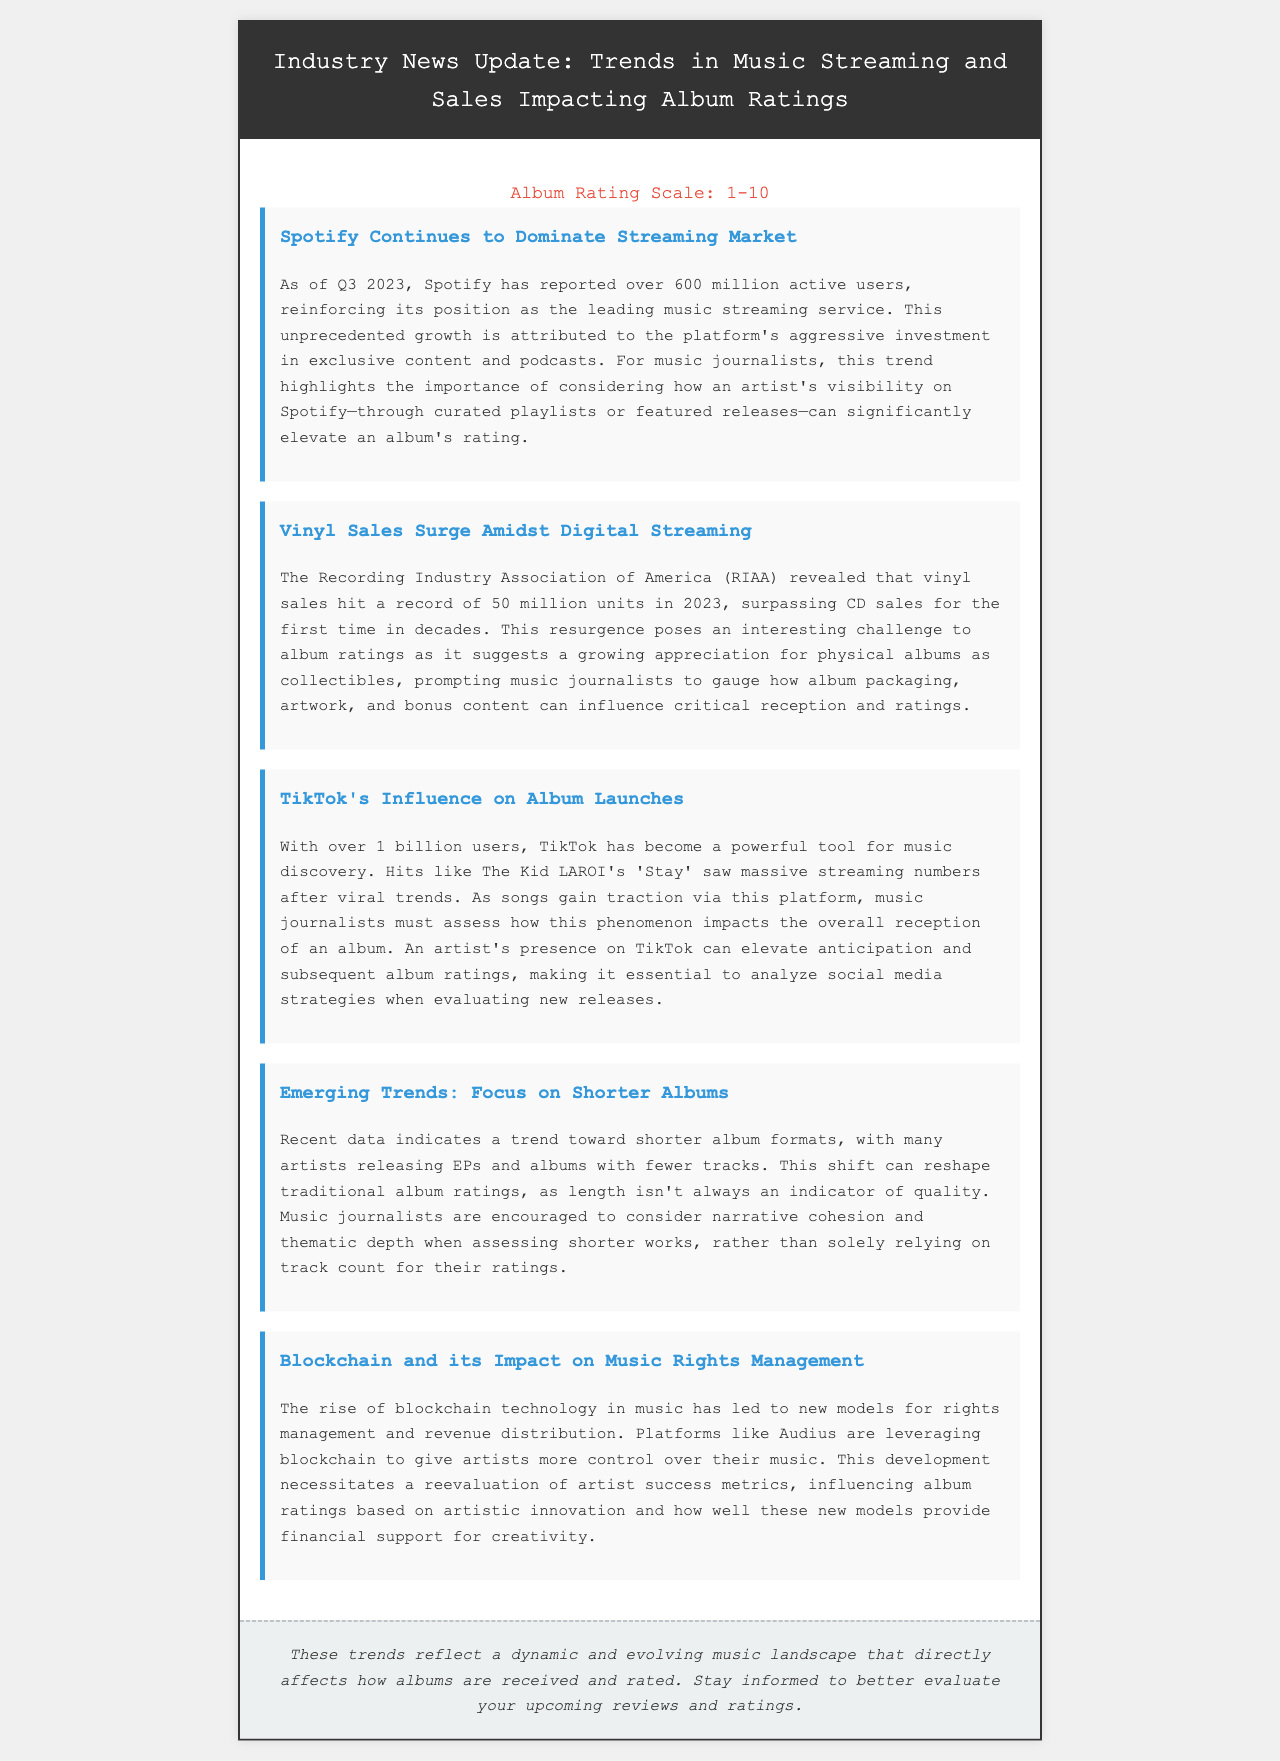What is the number of Spotify's active users as of Q3 2023? The document states that Spotify has reported over 600 million active users in Q3 2023.
Answer: 600 million What record did vinyl sales hit in 2023? The document mentions that vinyl sales hit a record of 50 million units in 2023.
Answer: 50 million units Which platform has over 1 billion users and influences music discovery? The document specifies TikTok as the platform with over 1 billion users influencing music discovery.
Answer: TikTok What trend is indicated regarding album formats? The document highlights a trend toward shorter album formats, particularly with many artists releasing EPs and albums with fewer tracks.
Answer: Shorter albums What is the impact of blockchain on music according to the document? The document states that the rise of blockchain technology has led to new models for rights management and revenue distribution in music.
Answer: Rights management How does Spotify's growth affect album ratings? The document discusses how an artist's visibility on Spotify, through curated playlists or featured releases, can significantly elevate an album's rating.
Answer: Elevate album ratings What should music journalists focus on when assessing shorter albums? The document suggests that music journalists should consider narrative cohesion and thematic depth when assessing shorter works.
Answer: Narrative cohesion and thematic depth What does TikTok's influence suggest about album anticipation? The document states that an artist's presence on TikTok can elevate anticipation for an album.
Answer: Elevate anticipation What is the main conclusion emphasized in the closing of the document? The closing emphasizes the importance of staying informed about trends affecting how albums are received and rated.
Answer: Staying informed 